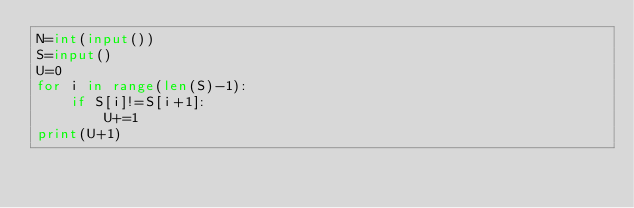Convert code to text. <code><loc_0><loc_0><loc_500><loc_500><_Python_>N=int(input())
S=input()
U=0
for i in range(len(S)-1):
    if S[i]!=S[i+1]:
        U+=1
print(U+1)</code> 